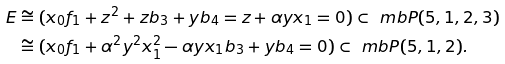Convert formula to latex. <formula><loc_0><loc_0><loc_500><loc_500>E & \cong ( x _ { 0 } f _ { 1 } + z ^ { 2 } + z b _ { 3 } + y b _ { 4 } = z + \alpha y x _ { 1 } = 0 ) \subset \ m b P ( 5 , 1 , 2 , 3 ) \\ & \cong ( x _ { 0 } f _ { 1 } + \alpha ^ { 2 } y ^ { 2 } x _ { 1 } ^ { 2 } - \alpha y x _ { 1 } b _ { 3 } + y b _ { 4 } = 0 ) \subset \ m b P ( 5 , 1 , 2 ) .</formula> 